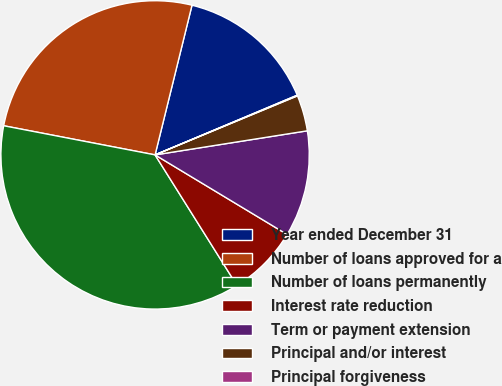Convert chart. <chart><loc_0><loc_0><loc_500><loc_500><pie_chart><fcel>Year ended December 31<fcel>Number of loans approved for a<fcel>Number of loans permanently<fcel>Interest rate reduction<fcel>Term or payment extension<fcel>Principal and/or interest<fcel>Principal forgiveness<nl><fcel>14.82%<fcel>25.82%<fcel>36.94%<fcel>7.45%<fcel>11.13%<fcel>3.76%<fcel>0.07%<nl></chart> 